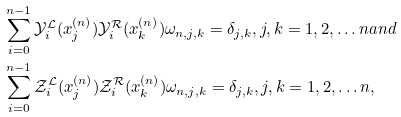<formula> <loc_0><loc_0><loc_500><loc_500>& \sum _ { i = 0 } ^ { n - 1 } \mathcal { Y } _ { i } ^ { \mathcal { L } } ( x _ { j } ^ { ( n ) } ) \mathcal { Y } _ { i } ^ { \mathcal { R } } ( x _ { k } ^ { ( n ) } ) \omega _ { n , j , k } = \delta _ { j , k } , j , k = 1 , 2 , \dots n a n d \\ & \sum _ { i = 0 } ^ { n - 1 } \mathcal { Z } _ { i } ^ { \mathcal { L } } ( x _ { j } ^ { ( n ) } ) \mathcal { Z } _ { i } ^ { \mathcal { R } } ( x _ { k } ^ { ( n ) } ) \omega _ { n , j , k } = \delta _ { j , k } , j , k = 1 , 2 , \dots n ,</formula> 